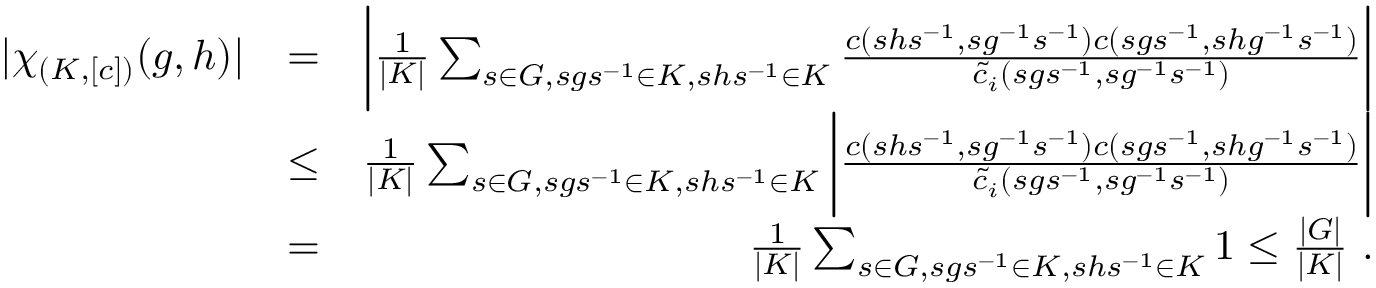Convert formula to latex. <formula><loc_0><loc_0><loc_500><loc_500>\begin{array} { r l r } { | \chi _ { ( K , [ c ] ) } ( g , h ) | } & { = } & { \left | \frac { 1 } { | K | } \sum _ { s \in G , s g s ^ { - 1 } \in K , s h s ^ { - 1 } \in K } \frac { c ( s h s ^ { - 1 } , s g ^ { - 1 } s ^ { - 1 } ) c ( s g s ^ { - 1 } , s h g ^ { - 1 } s ^ { - 1 } ) } { \tilde { c } _ { i } ( s g s ^ { - 1 } , s g ^ { - 1 } s ^ { - 1 } ) } \right | } \\ & { \leq } & { \frac { 1 } { | K | } \sum _ { s \in G , s g s ^ { - 1 } \in K , s h s ^ { - 1 } \in K } \left | \frac { c ( s h s ^ { - 1 } , s g ^ { - 1 } s ^ { - 1 } ) c ( s g s ^ { - 1 } , s h g ^ { - 1 } s ^ { - 1 } ) } { \tilde { c } _ { i } ( s g s ^ { - 1 } , s g ^ { - 1 } s ^ { - 1 } ) } \right | } \\ & { = } & { \frac { 1 } { | K | } \sum _ { s \in G , s g s ^ { - 1 } \in K , s h s ^ { - 1 } \in K } 1 \leq \frac { | G | } { | K | } . } \end{array}</formula> 